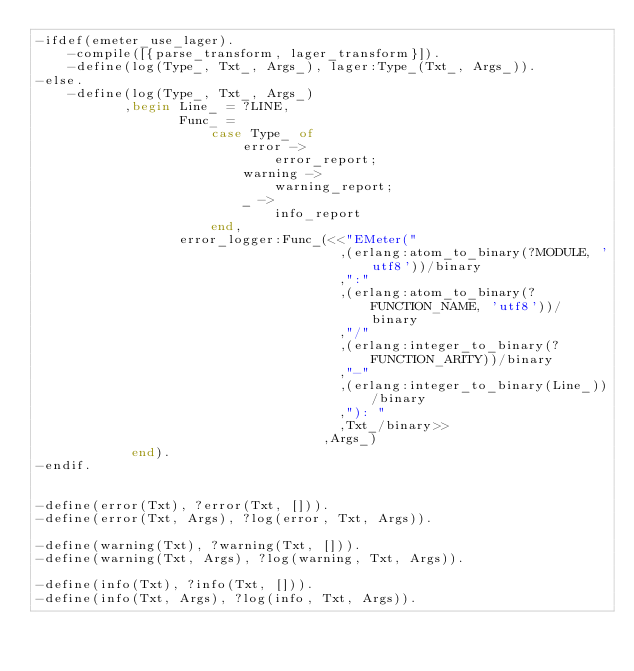Convert code to text. <code><loc_0><loc_0><loc_500><loc_500><_Erlang_>-ifdef(emeter_use_lager).
    -compile([{parse_transform, lager_transform}]).
    -define(log(Type_, Txt_, Args_), lager:Type_(Txt_, Args_)).
-else.
    -define(log(Type_, Txt_, Args_)
           ,begin Line_ = ?LINE,
                  Func_ =
                      case Type_ of
                          error ->
                              error_report;
                          warning ->
                              warning_report;
                          _ ->
                              info_report
                      end,
                  error_logger:Func_(<<"EMeter("
                                      ,(erlang:atom_to_binary(?MODULE, 'utf8'))/binary
                                      ,":"
                                      ,(erlang:atom_to_binary(?FUNCTION_NAME, 'utf8'))/binary
                                      ,"/"
                                      ,(erlang:integer_to_binary(?FUNCTION_ARITY))/binary
                                      ,"-"
                                      ,(erlang:integer_to_binary(Line_))/binary
                                      ,"): "
                                      ,Txt_/binary>>
                                    ,Args_)
            end).
-endif.


-define(error(Txt), ?error(Txt, [])).
-define(error(Txt, Args), ?log(error, Txt, Args)).

-define(warning(Txt), ?warning(Txt, [])).
-define(warning(Txt, Args), ?log(warning, Txt, Args)).

-define(info(Txt), ?info(Txt, [])).
-define(info(Txt, Args), ?log(info, Txt, Args)).</code> 